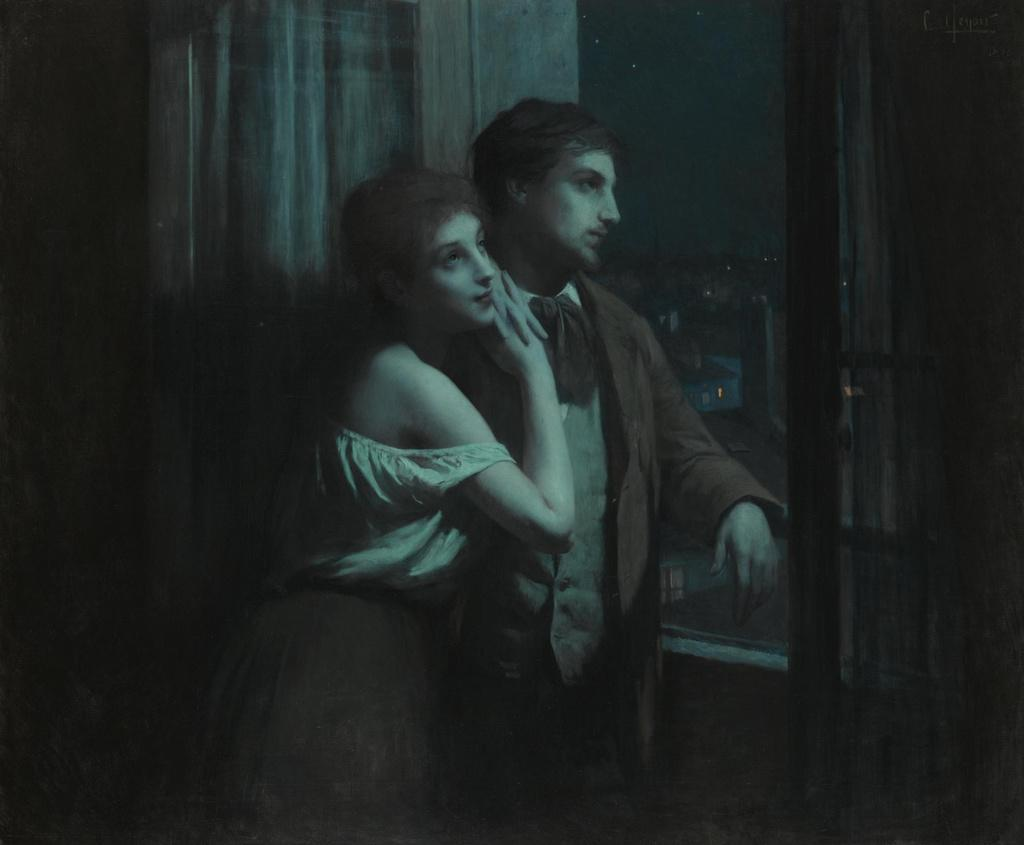How many people are in the image? There are two persons standing in the image. Can you describe the clothing of the person on the right? The person on the right is wearing a brown and white color dress. What can be seen in the background of the image? There is a window visible in the background of the image. What is the color of the sky in the image? The sky appears to be black in color. What type of insurance policy is being discussed by the two persons in the image? There is no indication in the image that the two persons are discussing any insurance policies. 